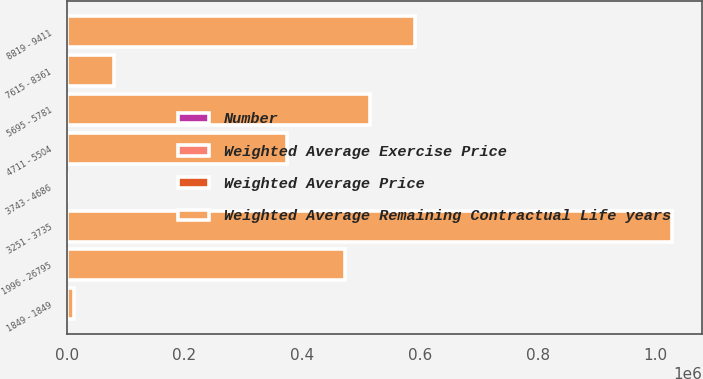Convert chart to OTSL. <chart><loc_0><loc_0><loc_500><loc_500><stacked_bar_chart><ecel><fcel>1849 - 1849<fcel>1996 - 26795<fcel>3251 - 3735<fcel>3743 - 4686<fcel>4711 - 5504<fcel>5695 - 5781<fcel>7615 - 8361<fcel>8819 - 9411<nl><fcel>Weighted Average Remaining Contractual Life years<fcel>12000<fcel>472085<fcel>1.02755e+06<fcel>42.84<fcel>373550<fcel>515375<fcel>79375<fcel>590624<nl><fcel>Weighted Average Price<fcel>0.42<fcel>0.94<fcel>5.83<fcel>4.94<fcel>7.8<fcel>1.73<fcel>3.24<fcel>2.58<nl><fcel>Number<fcel>18.49<fcel>20.96<fcel>37.15<fcel>42.81<fcel>48.39<fcel>56.97<fcel>81.34<fcel>92.57<nl><fcel>Weighted Average Exercise Price<fcel>18.49<fcel>20.96<fcel>37.33<fcel>42.84<fcel>48.28<fcel>56.97<fcel>81.34<fcel>92.57<nl></chart> 